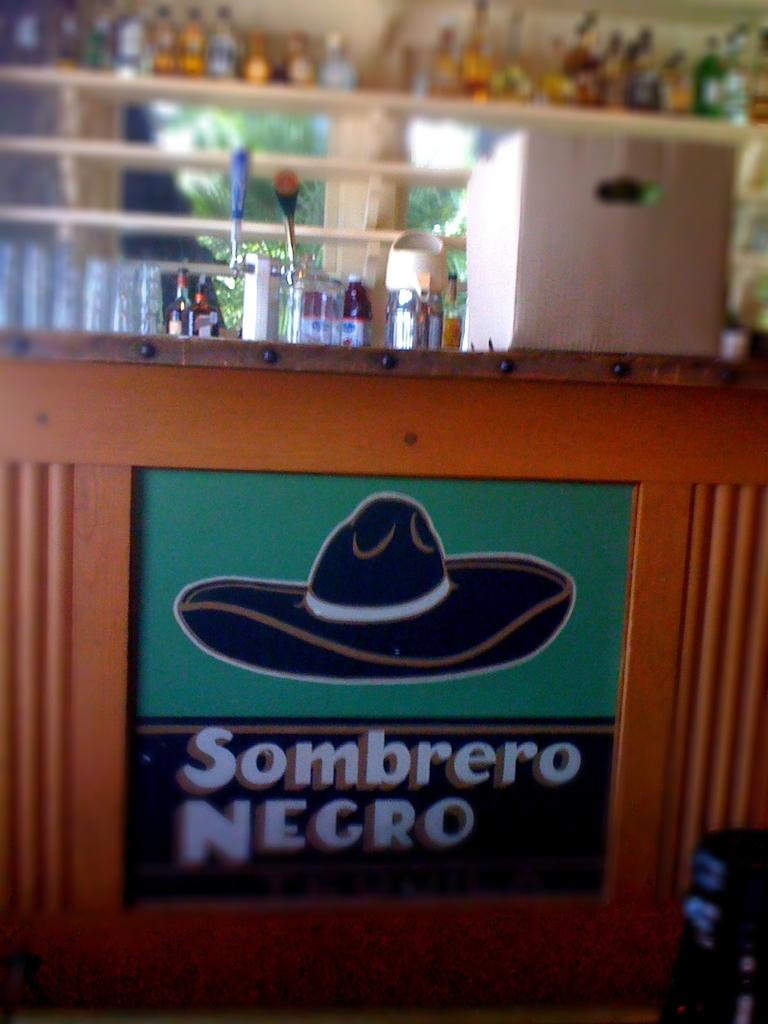<image>
Write a terse but informative summary of the picture. a blurry bar with a sign that reads Sombrero Negro on it 